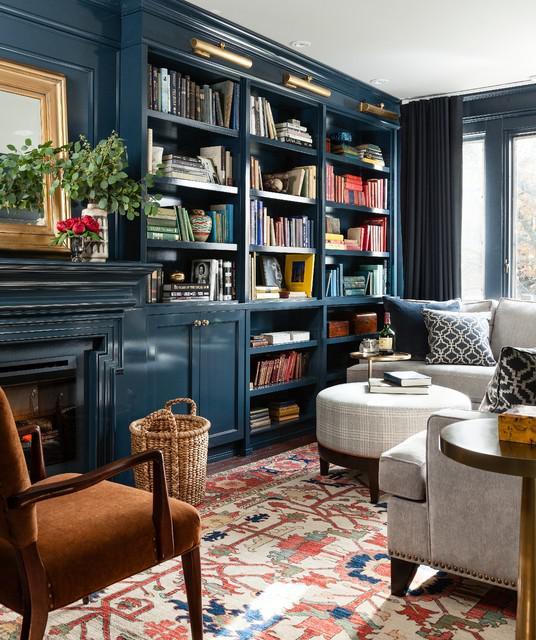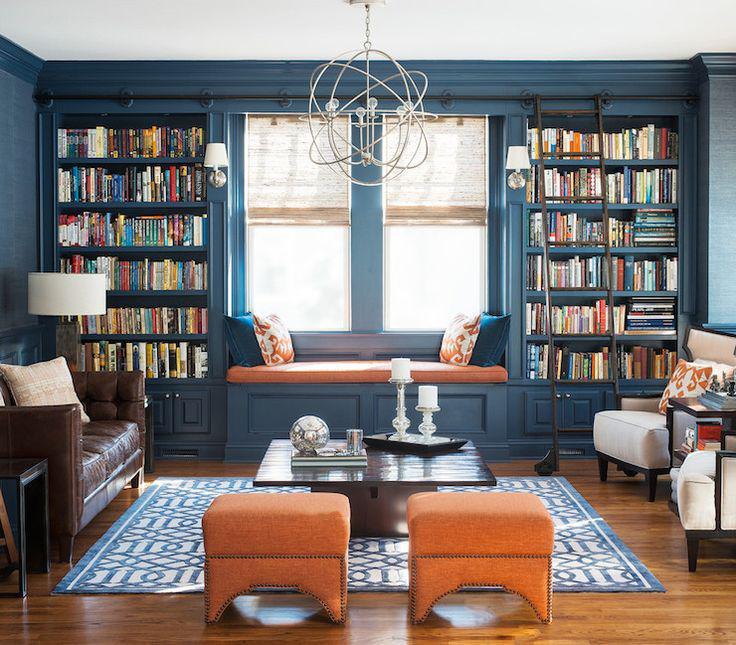The first image is the image on the left, the second image is the image on the right. For the images shown, is this caption "A light fixture is suspended at the center of the room in the right image." true? Answer yes or no. Yes. 